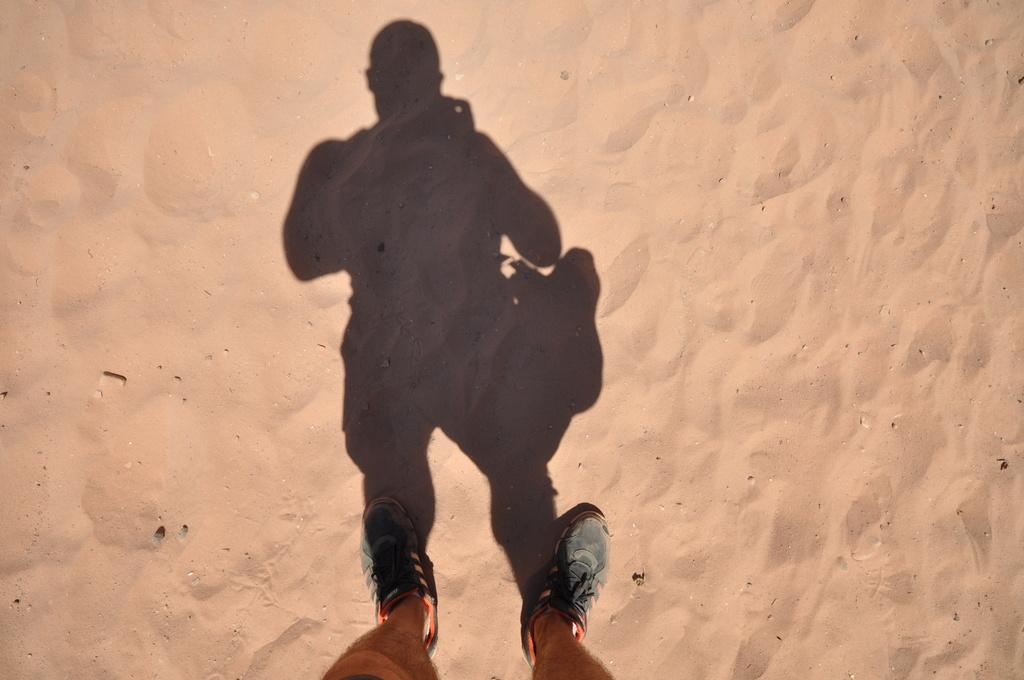What is the main subject in the image? There is a man standing in the image. Where is the man standing? The man is standing on the ground. What type of terrain is visible at the bottom of the image? There is sand at the bottom of the image. Can you describe any additional features related to the man in the image? There is a shadow of the man on the ground in the image. What type of mountain can be seen in the background of the image? There is no mountain visible in the image; it features a man standing on sandy ground. 